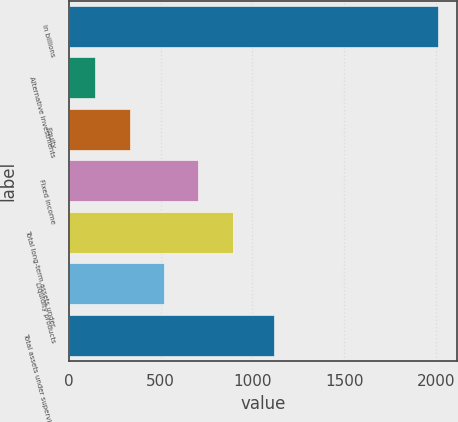Convert chart. <chart><loc_0><loc_0><loc_500><loc_500><bar_chart><fcel>in billions<fcel>Alternative investments<fcel>Equity<fcel>Fixed income<fcel>Total long-term assets under<fcel>Liquidity products<fcel>Total assets under supervision<nl><fcel>2014<fcel>145<fcel>331.9<fcel>705.7<fcel>892.6<fcel>518.8<fcel>1117<nl></chart> 